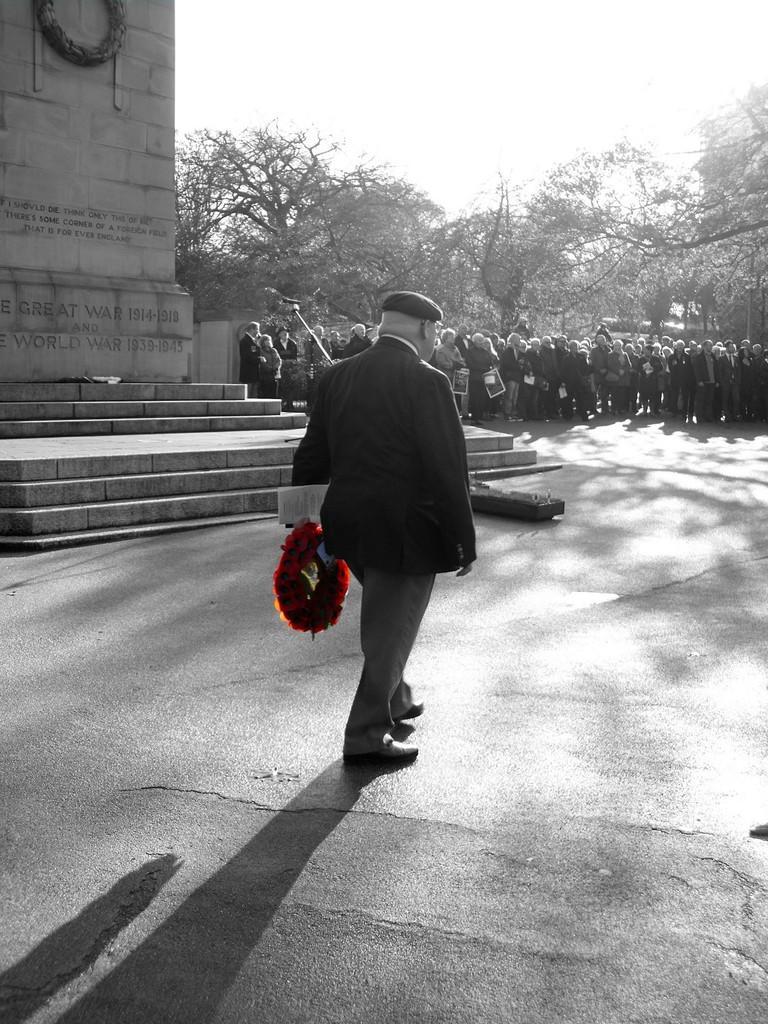Describe this image in one or two sentences. In this image we can see persons standing on the road and one of them is holding bouquet in the hands. In the background we can see a laid stone, staircase, trees and sky. 